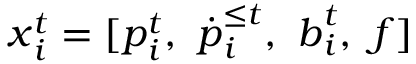Convert formula to latex. <formula><loc_0><loc_0><loc_500><loc_500>x _ { i } ^ { t } = [ p _ { i } ^ { t } , \ { \dot { p } } _ { i } ^ { \leq t } , \ b _ { i } ^ { t } , \ f ]</formula> 